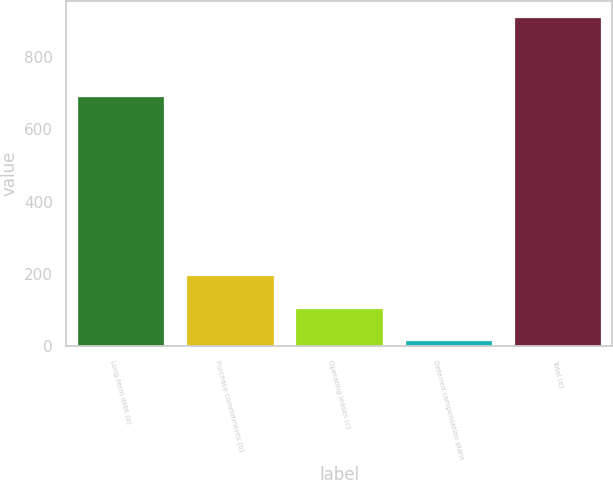<chart> <loc_0><loc_0><loc_500><loc_500><bar_chart><fcel>Long-term debt (a)<fcel>Purchase commitments (b)<fcel>Operating leases (c)<fcel>Deferred compensation plans<fcel>Total (e)<nl><fcel>692<fcel>196.2<fcel>107.1<fcel>18<fcel>909<nl></chart> 